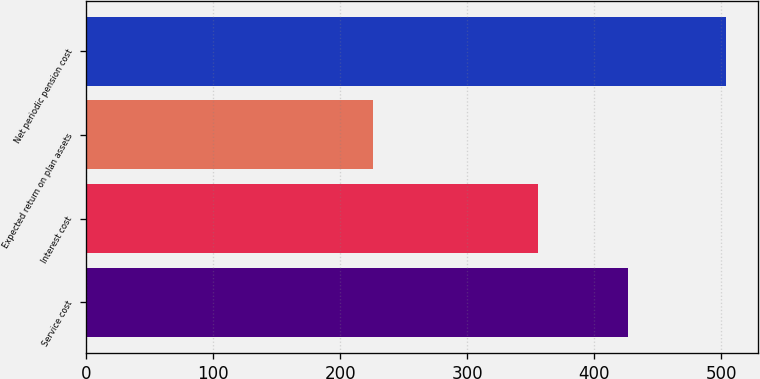Convert chart to OTSL. <chart><loc_0><loc_0><loc_500><loc_500><bar_chart><fcel>Service cost<fcel>Interest cost<fcel>Expected return on plan assets<fcel>Net periodic pension cost<nl><fcel>427<fcel>356<fcel>226<fcel>504<nl></chart> 